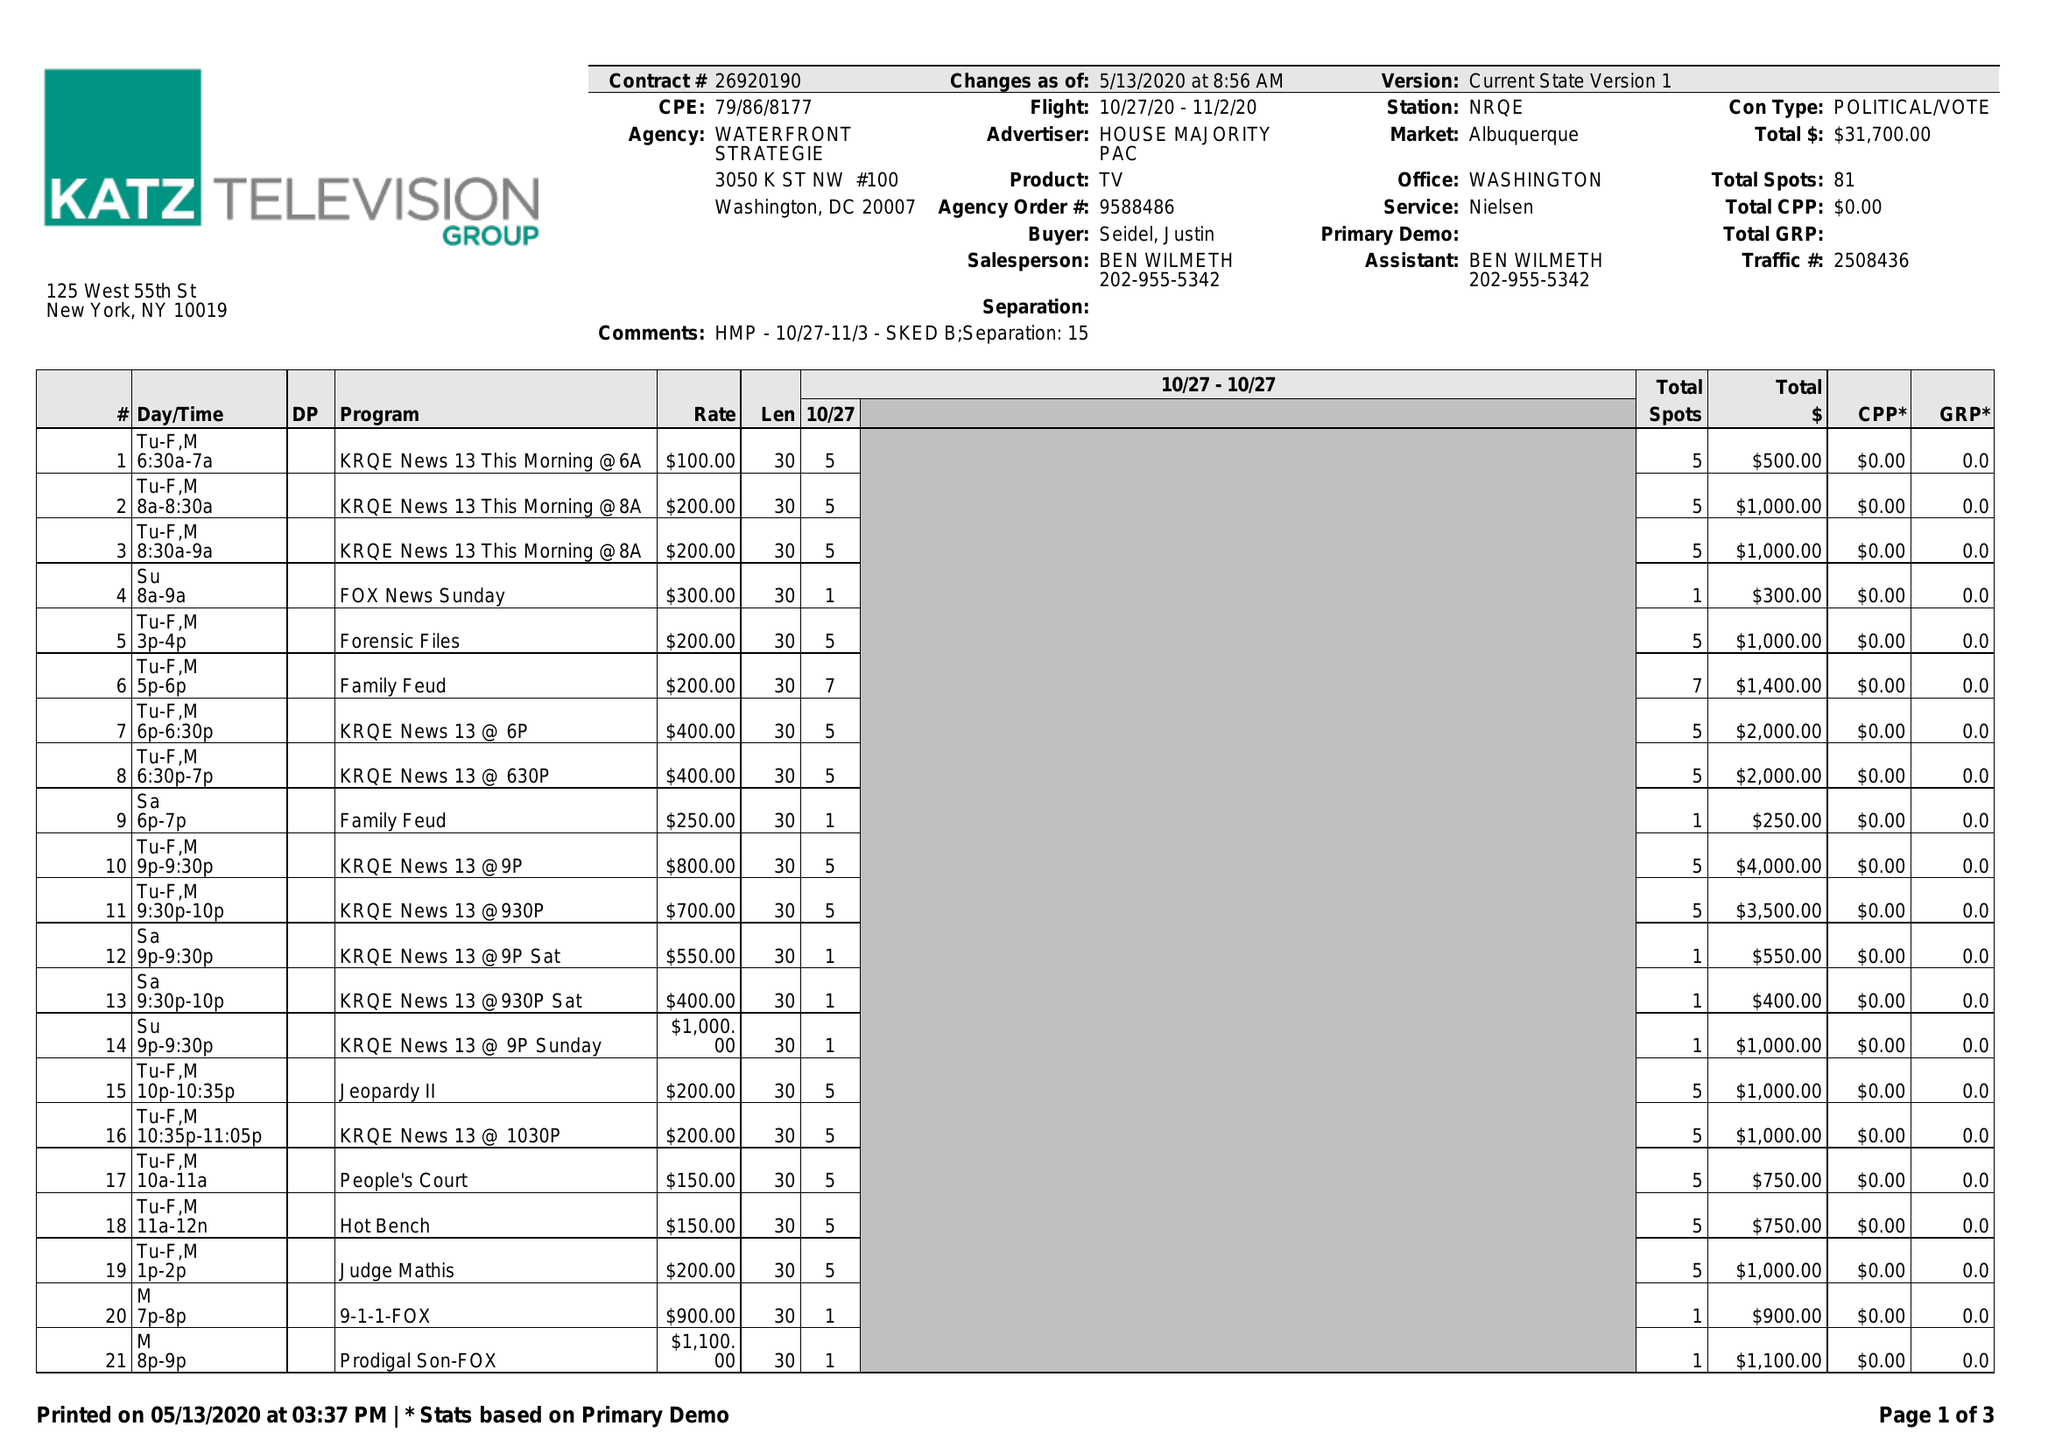What is the value for the flight_to?
Answer the question using a single word or phrase. 11/02/20 